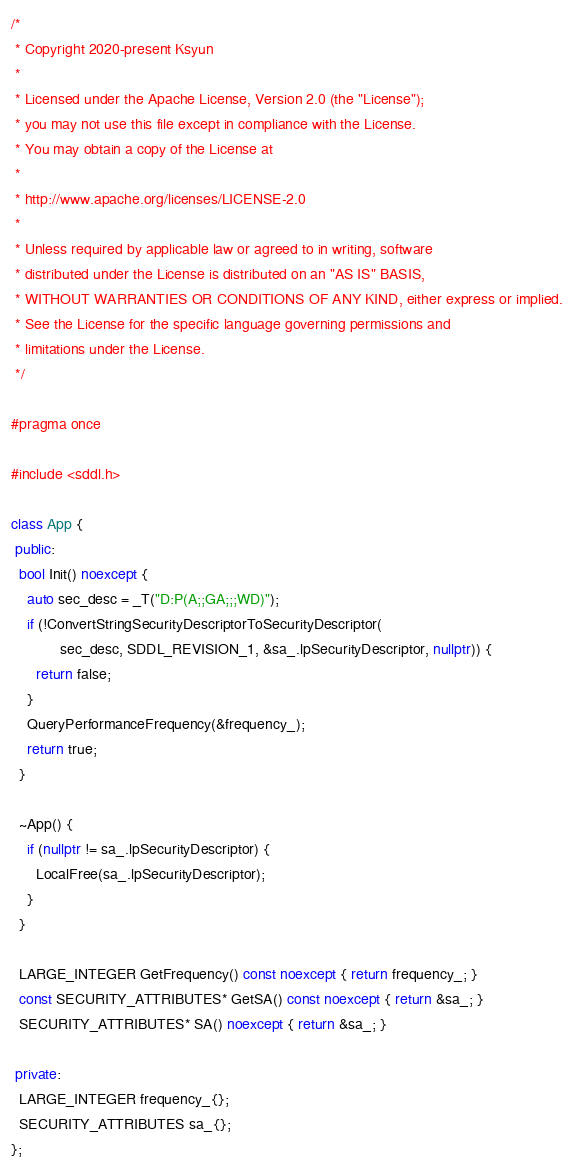Convert code to text. <code><loc_0><loc_0><loc_500><loc_500><_C++_>/*
 * Copyright 2020-present Ksyun
 *
 * Licensed under the Apache License, Version 2.0 (the "License");
 * you may not use this file except in compliance with the License.
 * You may obtain a copy of the License at
 *
 * http://www.apache.org/licenses/LICENSE-2.0
 *
 * Unless required by applicable law or agreed to in writing, software
 * distributed under the License is distributed on an "AS IS" BASIS,
 * WITHOUT WARRANTIES OR CONDITIONS OF ANY KIND, either express or implied.
 * See the License for the specific language governing permissions and
 * limitations under the License.
 */

#pragma once

#include <sddl.h>

class App {
 public:
  bool Init() noexcept {
    auto sec_desc = _T("D:P(A;;GA;;;WD)");
    if (!ConvertStringSecurityDescriptorToSecurityDescriptor(
            sec_desc, SDDL_REVISION_1, &sa_.lpSecurityDescriptor, nullptr)) {
      return false;
    }
    QueryPerformanceFrequency(&frequency_);
    return true;
  }

  ~App() {
    if (nullptr != sa_.lpSecurityDescriptor) {
      LocalFree(sa_.lpSecurityDescriptor);
    }
  }

  LARGE_INTEGER GetFrequency() const noexcept { return frequency_; }
  const SECURITY_ATTRIBUTES* GetSA() const noexcept { return &sa_; }
  SECURITY_ATTRIBUTES* SA() noexcept { return &sa_; }

 private:
  LARGE_INTEGER frequency_{};
  SECURITY_ATTRIBUTES sa_{};
};
</code> 